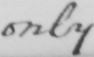Transcribe the text shown in this historical manuscript line. only 